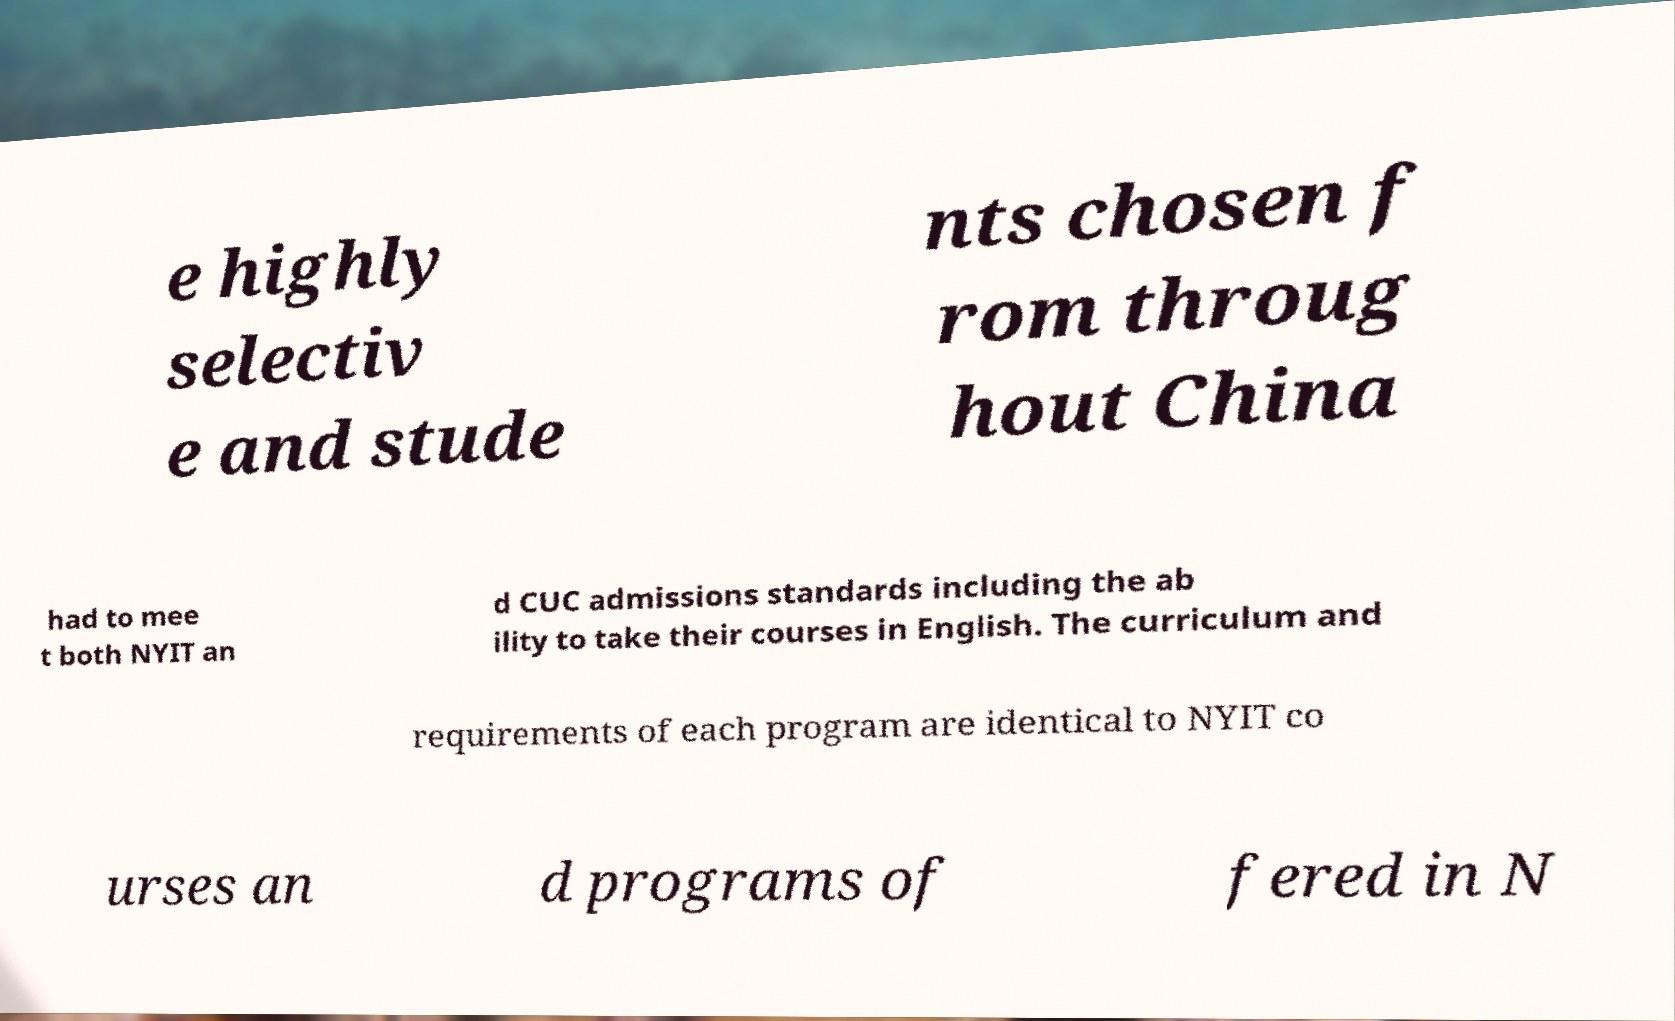Please identify and transcribe the text found in this image. e highly selectiv e and stude nts chosen f rom throug hout China had to mee t both NYIT an d CUC admissions standards including the ab ility to take their courses in English. The curriculum and requirements of each program are identical to NYIT co urses an d programs of fered in N 